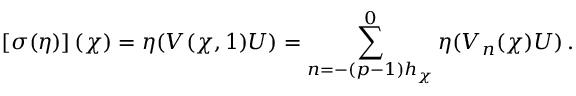Convert formula to latex. <formula><loc_0><loc_0><loc_500><loc_500>\left [ \sigma ( \eta ) \right ] ( \chi ) = \eta ( V ( \chi , 1 ) U ) = \sum _ { n = - ( p - 1 ) h _ { \chi } } ^ { 0 } \eta ( V _ { n } ( \chi ) U ) \, .</formula> 